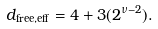Convert formula to latex. <formula><loc_0><loc_0><loc_500><loc_500>d _ { \text {free,eff} } = 4 + 3 ( 2 ^ { \nu - 2 } ) .</formula> 